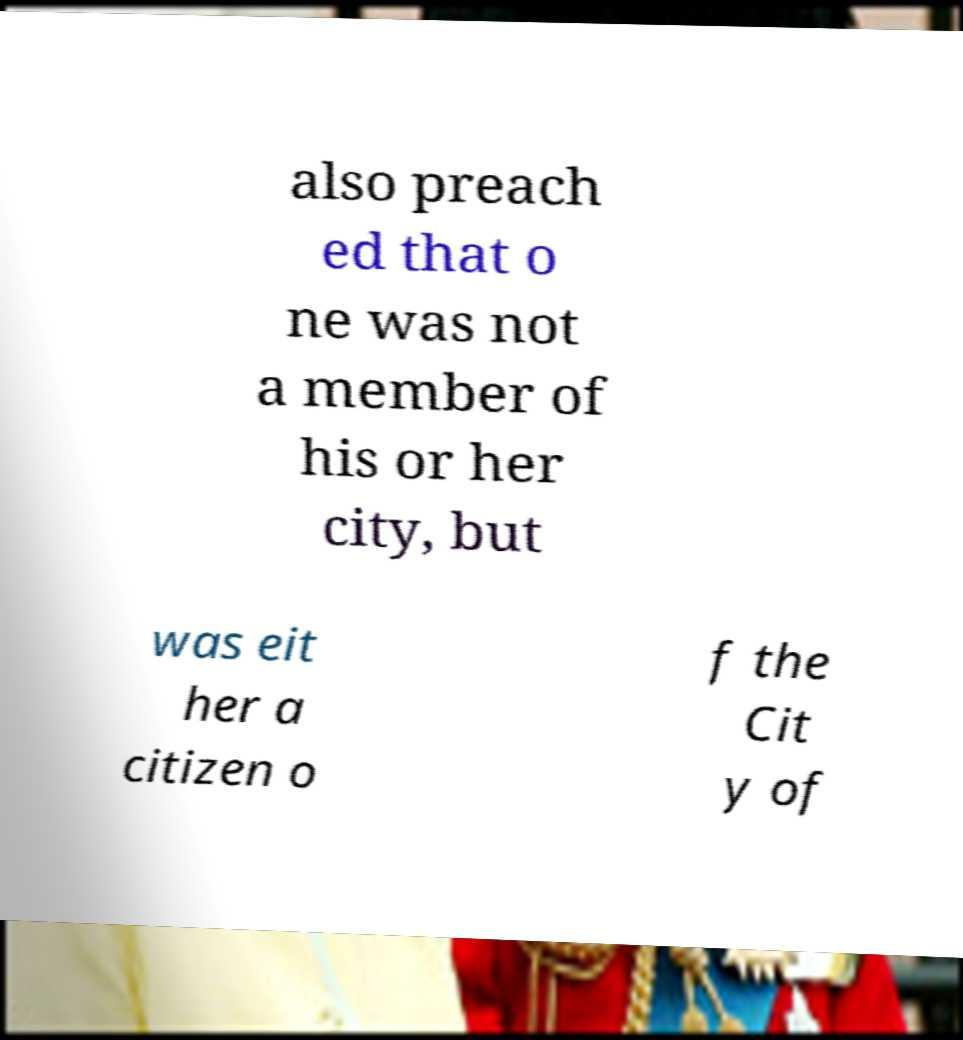Please identify and transcribe the text found in this image. also preach ed that o ne was not a member of his or her city, but was eit her a citizen o f the Cit y of 